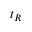Convert formula to latex. <formula><loc_0><loc_0><loc_500><loc_500>t _ { R }</formula> 